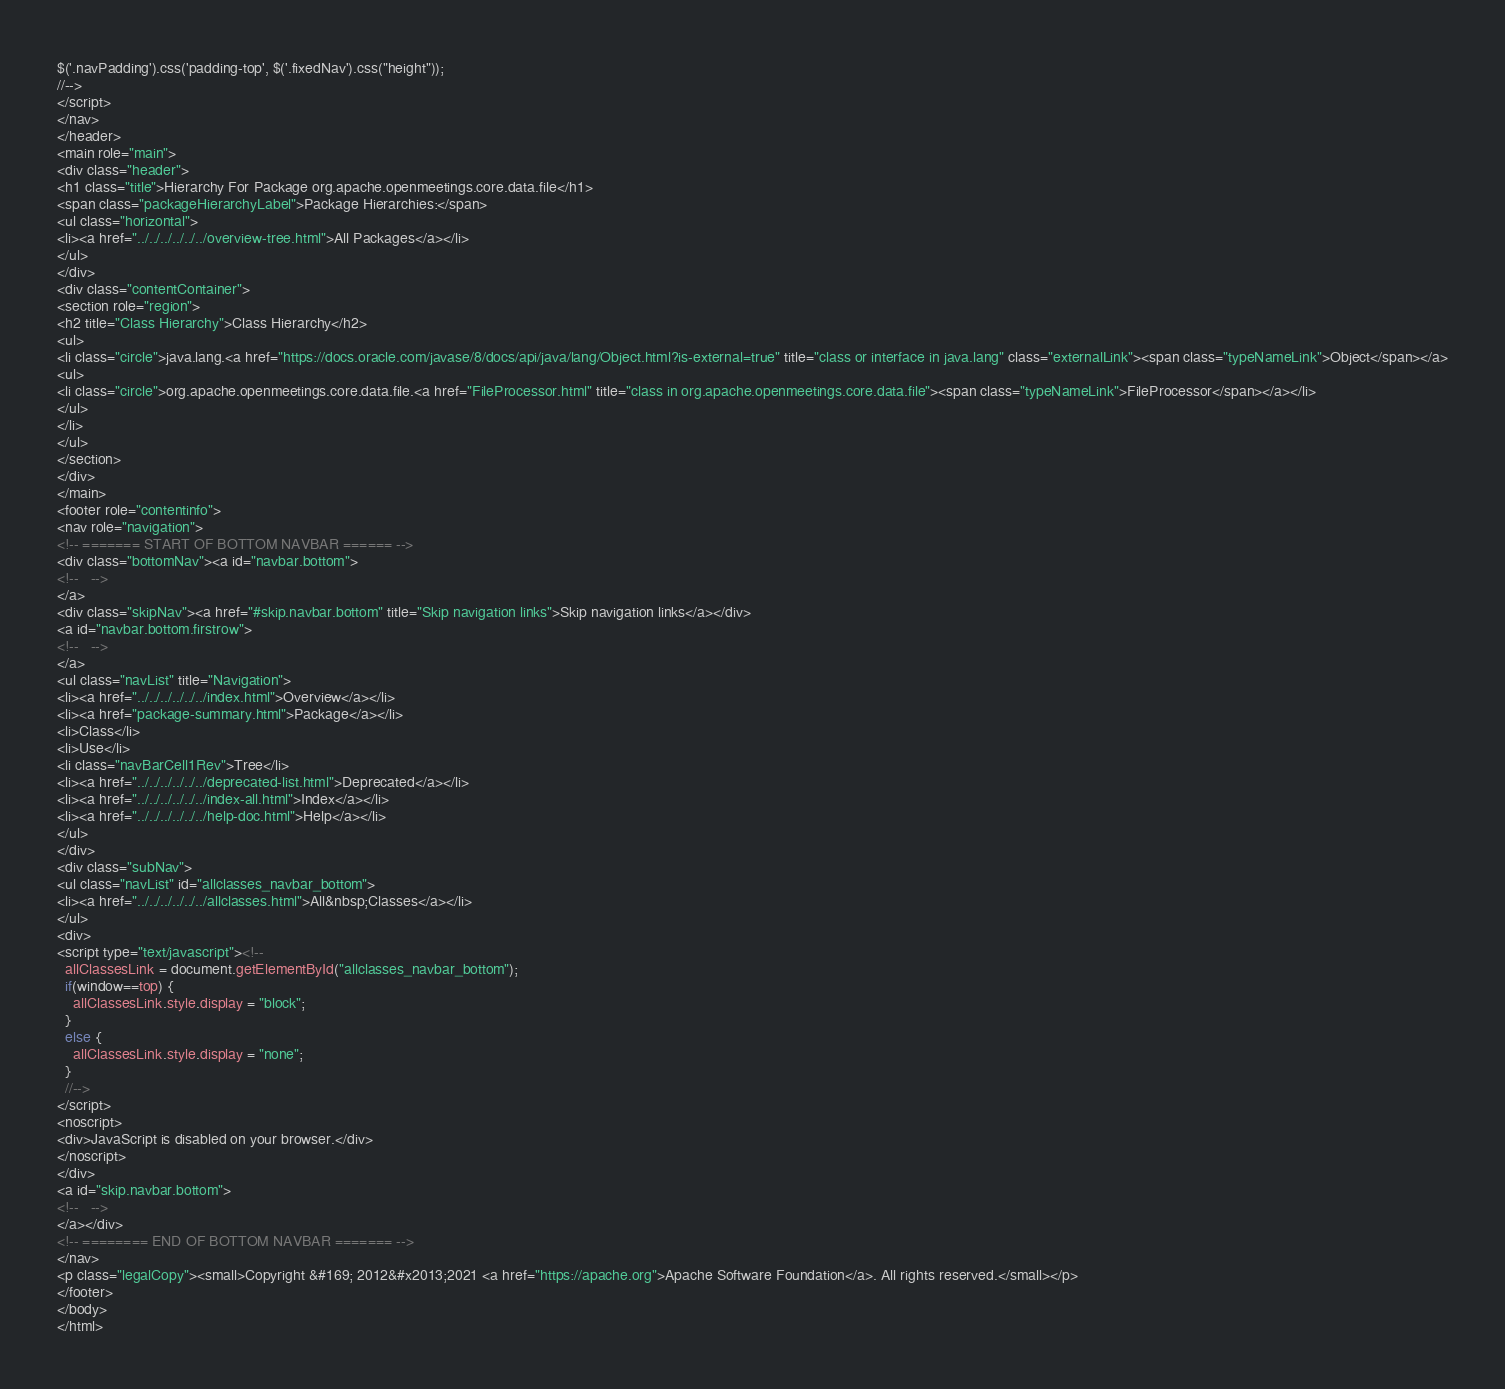Convert code to text. <code><loc_0><loc_0><loc_500><loc_500><_HTML_>$('.navPadding').css('padding-top', $('.fixedNav').css("height"));
//-->
</script>
</nav>
</header>
<main role="main">
<div class="header">
<h1 class="title">Hierarchy For Package org.apache.openmeetings.core.data.file</h1>
<span class="packageHierarchyLabel">Package Hierarchies:</span>
<ul class="horizontal">
<li><a href="../../../../../../overview-tree.html">All Packages</a></li>
</ul>
</div>
<div class="contentContainer">
<section role="region">
<h2 title="Class Hierarchy">Class Hierarchy</h2>
<ul>
<li class="circle">java.lang.<a href="https://docs.oracle.com/javase/8/docs/api/java/lang/Object.html?is-external=true" title="class or interface in java.lang" class="externalLink"><span class="typeNameLink">Object</span></a>
<ul>
<li class="circle">org.apache.openmeetings.core.data.file.<a href="FileProcessor.html" title="class in org.apache.openmeetings.core.data.file"><span class="typeNameLink">FileProcessor</span></a></li>
</ul>
</li>
</ul>
</section>
</div>
</main>
<footer role="contentinfo">
<nav role="navigation">
<!-- ======= START OF BOTTOM NAVBAR ====== -->
<div class="bottomNav"><a id="navbar.bottom">
<!--   -->
</a>
<div class="skipNav"><a href="#skip.navbar.bottom" title="Skip navigation links">Skip navigation links</a></div>
<a id="navbar.bottom.firstrow">
<!--   -->
</a>
<ul class="navList" title="Navigation">
<li><a href="../../../../../../index.html">Overview</a></li>
<li><a href="package-summary.html">Package</a></li>
<li>Class</li>
<li>Use</li>
<li class="navBarCell1Rev">Tree</li>
<li><a href="../../../../../../deprecated-list.html">Deprecated</a></li>
<li><a href="../../../../../../index-all.html">Index</a></li>
<li><a href="../../../../../../help-doc.html">Help</a></li>
</ul>
</div>
<div class="subNav">
<ul class="navList" id="allclasses_navbar_bottom">
<li><a href="../../../../../../allclasses.html">All&nbsp;Classes</a></li>
</ul>
<div>
<script type="text/javascript"><!--
  allClassesLink = document.getElementById("allclasses_navbar_bottom");
  if(window==top) {
    allClassesLink.style.display = "block";
  }
  else {
    allClassesLink.style.display = "none";
  }
  //-->
</script>
<noscript>
<div>JavaScript is disabled on your browser.</div>
</noscript>
</div>
<a id="skip.navbar.bottom">
<!--   -->
</a></div>
<!-- ======== END OF BOTTOM NAVBAR ======= -->
</nav>
<p class="legalCopy"><small>Copyright &#169; 2012&#x2013;2021 <a href="https://apache.org">Apache Software Foundation</a>. All rights reserved.</small></p>
</footer>
</body>
</html>
</code> 